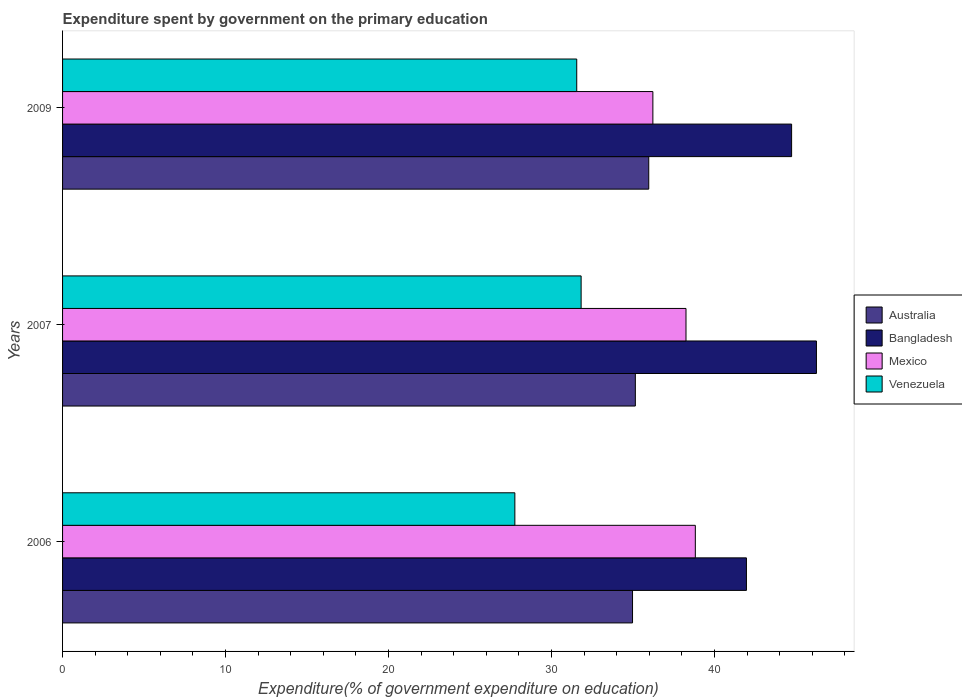How many different coloured bars are there?
Provide a succinct answer. 4. How many groups of bars are there?
Ensure brevity in your answer.  3. Are the number of bars per tick equal to the number of legend labels?
Give a very brief answer. Yes. How many bars are there on the 1st tick from the bottom?
Your answer should be very brief. 4. What is the expenditure spent by government on the primary education in Mexico in 2009?
Offer a very short reply. 36.22. Across all years, what is the maximum expenditure spent by government on the primary education in Mexico?
Your answer should be very brief. 38.82. Across all years, what is the minimum expenditure spent by government on the primary education in Venezuela?
Your answer should be very brief. 27.75. In which year was the expenditure spent by government on the primary education in Australia minimum?
Ensure brevity in your answer.  2006. What is the total expenditure spent by government on the primary education in Mexico in the graph?
Your answer should be compact. 113.29. What is the difference between the expenditure spent by government on the primary education in Australia in 2007 and that in 2009?
Give a very brief answer. -0.82. What is the difference between the expenditure spent by government on the primary education in Australia in 2006 and the expenditure spent by government on the primary education in Bangladesh in 2009?
Your response must be concise. -9.76. What is the average expenditure spent by government on the primary education in Mexico per year?
Provide a succinct answer. 37.76. In the year 2007, what is the difference between the expenditure spent by government on the primary education in Bangladesh and expenditure spent by government on the primary education in Mexico?
Your response must be concise. 8. In how many years, is the expenditure spent by government on the primary education in Australia greater than 46 %?
Your answer should be compact. 0. What is the ratio of the expenditure spent by government on the primary education in Australia in 2006 to that in 2007?
Keep it short and to the point. 1. Is the difference between the expenditure spent by government on the primary education in Bangladesh in 2006 and 2007 greater than the difference between the expenditure spent by government on the primary education in Mexico in 2006 and 2007?
Offer a very short reply. No. What is the difference between the highest and the second highest expenditure spent by government on the primary education in Mexico?
Make the answer very short. 0.57. What is the difference between the highest and the lowest expenditure spent by government on the primary education in Australia?
Make the answer very short. 1. In how many years, is the expenditure spent by government on the primary education in Bangladesh greater than the average expenditure spent by government on the primary education in Bangladesh taken over all years?
Your answer should be very brief. 2. Is the sum of the expenditure spent by government on the primary education in Australia in 2006 and 2007 greater than the maximum expenditure spent by government on the primary education in Venezuela across all years?
Your answer should be compact. Yes. What does the 2nd bar from the top in 2007 represents?
Offer a terse response. Mexico. How many bars are there?
Offer a very short reply. 12. What is the difference between two consecutive major ticks on the X-axis?
Your response must be concise. 10. Are the values on the major ticks of X-axis written in scientific E-notation?
Make the answer very short. No. Where does the legend appear in the graph?
Ensure brevity in your answer.  Center right. How many legend labels are there?
Your response must be concise. 4. What is the title of the graph?
Your answer should be very brief. Expenditure spent by government on the primary education. What is the label or title of the X-axis?
Provide a short and direct response. Expenditure(% of government expenditure on education). What is the label or title of the Y-axis?
Ensure brevity in your answer.  Years. What is the Expenditure(% of government expenditure on education) of Australia in 2006?
Ensure brevity in your answer.  34.97. What is the Expenditure(% of government expenditure on education) in Bangladesh in 2006?
Offer a terse response. 41.96. What is the Expenditure(% of government expenditure on education) of Mexico in 2006?
Provide a succinct answer. 38.82. What is the Expenditure(% of government expenditure on education) of Venezuela in 2006?
Give a very brief answer. 27.75. What is the Expenditure(% of government expenditure on education) of Australia in 2007?
Keep it short and to the point. 35.14. What is the Expenditure(% of government expenditure on education) of Bangladesh in 2007?
Your answer should be very brief. 46.25. What is the Expenditure(% of government expenditure on education) of Mexico in 2007?
Keep it short and to the point. 38.25. What is the Expenditure(% of government expenditure on education) in Venezuela in 2007?
Keep it short and to the point. 31.81. What is the Expenditure(% of government expenditure on education) in Australia in 2009?
Your response must be concise. 35.96. What is the Expenditure(% of government expenditure on education) of Bangladesh in 2009?
Provide a succinct answer. 44.73. What is the Expenditure(% of government expenditure on education) in Mexico in 2009?
Your answer should be very brief. 36.22. What is the Expenditure(% of government expenditure on education) in Venezuela in 2009?
Offer a very short reply. 31.55. Across all years, what is the maximum Expenditure(% of government expenditure on education) in Australia?
Make the answer very short. 35.96. Across all years, what is the maximum Expenditure(% of government expenditure on education) of Bangladesh?
Provide a succinct answer. 46.25. Across all years, what is the maximum Expenditure(% of government expenditure on education) in Mexico?
Keep it short and to the point. 38.82. Across all years, what is the maximum Expenditure(% of government expenditure on education) in Venezuela?
Make the answer very short. 31.81. Across all years, what is the minimum Expenditure(% of government expenditure on education) in Australia?
Your answer should be very brief. 34.97. Across all years, what is the minimum Expenditure(% of government expenditure on education) in Bangladesh?
Offer a very short reply. 41.96. Across all years, what is the minimum Expenditure(% of government expenditure on education) of Mexico?
Your response must be concise. 36.22. Across all years, what is the minimum Expenditure(% of government expenditure on education) in Venezuela?
Your answer should be compact. 27.75. What is the total Expenditure(% of government expenditure on education) in Australia in the graph?
Your answer should be compact. 106.07. What is the total Expenditure(% of government expenditure on education) of Bangladesh in the graph?
Offer a terse response. 132.94. What is the total Expenditure(% of government expenditure on education) in Mexico in the graph?
Offer a very short reply. 113.29. What is the total Expenditure(% of government expenditure on education) in Venezuela in the graph?
Offer a very short reply. 91.11. What is the difference between the Expenditure(% of government expenditure on education) of Australia in 2006 and that in 2007?
Ensure brevity in your answer.  -0.17. What is the difference between the Expenditure(% of government expenditure on education) of Bangladesh in 2006 and that in 2007?
Offer a very short reply. -4.29. What is the difference between the Expenditure(% of government expenditure on education) of Mexico in 2006 and that in 2007?
Provide a short and direct response. 0.57. What is the difference between the Expenditure(% of government expenditure on education) in Venezuela in 2006 and that in 2007?
Provide a succinct answer. -4.07. What is the difference between the Expenditure(% of government expenditure on education) of Australia in 2006 and that in 2009?
Your response must be concise. -1. What is the difference between the Expenditure(% of government expenditure on education) in Bangladesh in 2006 and that in 2009?
Ensure brevity in your answer.  -2.77. What is the difference between the Expenditure(% of government expenditure on education) of Mexico in 2006 and that in 2009?
Your answer should be compact. 2.6. What is the difference between the Expenditure(% of government expenditure on education) in Venezuela in 2006 and that in 2009?
Ensure brevity in your answer.  -3.8. What is the difference between the Expenditure(% of government expenditure on education) of Australia in 2007 and that in 2009?
Offer a very short reply. -0.82. What is the difference between the Expenditure(% of government expenditure on education) of Bangladesh in 2007 and that in 2009?
Give a very brief answer. 1.52. What is the difference between the Expenditure(% of government expenditure on education) of Mexico in 2007 and that in 2009?
Provide a short and direct response. 2.03. What is the difference between the Expenditure(% of government expenditure on education) of Venezuela in 2007 and that in 2009?
Give a very brief answer. 0.27. What is the difference between the Expenditure(% of government expenditure on education) in Australia in 2006 and the Expenditure(% of government expenditure on education) in Bangladesh in 2007?
Your answer should be compact. -11.28. What is the difference between the Expenditure(% of government expenditure on education) of Australia in 2006 and the Expenditure(% of government expenditure on education) of Mexico in 2007?
Your answer should be compact. -3.28. What is the difference between the Expenditure(% of government expenditure on education) in Australia in 2006 and the Expenditure(% of government expenditure on education) in Venezuela in 2007?
Your answer should be very brief. 3.15. What is the difference between the Expenditure(% of government expenditure on education) in Bangladesh in 2006 and the Expenditure(% of government expenditure on education) in Mexico in 2007?
Your answer should be compact. 3.71. What is the difference between the Expenditure(% of government expenditure on education) in Bangladesh in 2006 and the Expenditure(% of government expenditure on education) in Venezuela in 2007?
Keep it short and to the point. 10.14. What is the difference between the Expenditure(% of government expenditure on education) of Mexico in 2006 and the Expenditure(% of government expenditure on education) of Venezuela in 2007?
Provide a succinct answer. 7.01. What is the difference between the Expenditure(% of government expenditure on education) in Australia in 2006 and the Expenditure(% of government expenditure on education) in Bangladesh in 2009?
Your answer should be compact. -9.76. What is the difference between the Expenditure(% of government expenditure on education) of Australia in 2006 and the Expenditure(% of government expenditure on education) of Mexico in 2009?
Offer a terse response. -1.25. What is the difference between the Expenditure(% of government expenditure on education) in Australia in 2006 and the Expenditure(% of government expenditure on education) in Venezuela in 2009?
Ensure brevity in your answer.  3.42. What is the difference between the Expenditure(% of government expenditure on education) in Bangladesh in 2006 and the Expenditure(% of government expenditure on education) in Mexico in 2009?
Keep it short and to the point. 5.74. What is the difference between the Expenditure(% of government expenditure on education) in Bangladesh in 2006 and the Expenditure(% of government expenditure on education) in Venezuela in 2009?
Offer a terse response. 10.41. What is the difference between the Expenditure(% of government expenditure on education) in Mexico in 2006 and the Expenditure(% of government expenditure on education) in Venezuela in 2009?
Your response must be concise. 7.28. What is the difference between the Expenditure(% of government expenditure on education) in Australia in 2007 and the Expenditure(% of government expenditure on education) in Bangladesh in 2009?
Offer a very short reply. -9.59. What is the difference between the Expenditure(% of government expenditure on education) in Australia in 2007 and the Expenditure(% of government expenditure on education) in Mexico in 2009?
Provide a short and direct response. -1.08. What is the difference between the Expenditure(% of government expenditure on education) in Australia in 2007 and the Expenditure(% of government expenditure on education) in Venezuela in 2009?
Your response must be concise. 3.6. What is the difference between the Expenditure(% of government expenditure on education) of Bangladesh in 2007 and the Expenditure(% of government expenditure on education) of Mexico in 2009?
Ensure brevity in your answer.  10.04. What is the difference between the Expenditure(% of government expenditure on education) in Bangladesh in 2007 and the Expenditure(% of government expenditure on education) in Venezuela in 2009?
Your answer should be very brief. 14.71. What is the difference between the Expenditure(% of government expenditure on education) in Mexico in 2007 and the Expenditure(% of government expenditure on education) in Venezuela in 2009?
Offer a terse response. 6.7. What is the average Expenditure(% of government expenditure on education) in Australia per year?
Give a very brief answer. 35.36. What is the average Expenditure(% of government expenditure on education) of Bangladesh per year?
Make the answer very short. 44.31. What is the average Expenditure(% of government expenditure on education) in Mexico per year?
Offer a terse response. 37.76. What is the average Expenditure(% of government expenditure on education) in Venezuela per year?
Provide a succinct answer. 30.37. In the year 2006, what is the difference between the Expenditure(% of government expenditure on education) of Australia and Expenditure(% of government expenditure on education) of Bangladesh?
Keep it short and to the point. -6.99. In the year 2006, what is the difference between the Expenditure(% of government expenditure on education) of Australia and Expenditure(% of government expenditure on education) of Mexico?
Provide a succinct answer. -3.85. In the year 2006, what is the difference between the Expenditure(% of government expenditure on education) in Australia and Expenditure(% of government expenditure on education) in Venezuela?
Ensure brevity in your answer.  7.22. In the year 2006, what is the difference between the Expenditure(% of government expenditure on education) in Bangladesh and Expenditure(% of government expenditure on education) in Mexico?
Your response must be concise. 3.14. In the year 2006, what is the difference between the Expenditure(% of government expenditure on education) in Bangladesh and Expenditure(% of government expenditure on education) in Venezuela?
Keep it short and to the point. 14.21. In the year 2006, what is the difference between the Expenditure(% of government expenditure on education) of Mexico and Expenditure(% of government expenditure on education) of Venezuela?
Keep it short and to the point. 11.07. In the year 2007, what is the difference between the Expenditure(% of government expenditure on education) of Australia and Expenditure(% of government expenditure on education) of Bangladesh?
Your response must be concise. -11.11. In the year 2007, what is the difference between the Expenditure(% of government expenditure on education) in Australia and Expenditure(% of government expenditure on education) in Mexico?
Keep it short and to the point. -3.11. In the year 2007, what is the difference between the Expenditure(% of government expenditure on education) in Australia and Expenditure(% of government expenditure on education) in Venezuela?
Your answer should be very brief. 3.33. In the year 2007, what is the difference between the Expenditure(% of government expenditure on education) of Bangladesh and Expenditure(% of government expenditure on education) of Mexico?
Your response must be concise. 8. In the year 2007, what is the difference between the Expenditure(% of government expenditure on education) in Bangladesh and Expenditure(% of government expenditure on education) in Venezuela?
Offer a very short reply. 14.44. In the year 2007, what is the difference between the Expenditure(% of government expenditure on education) of Mexico and Expenditure(% of government expenditure on education) of Venezuela?
Ensure brevity in your answer.  6.43. In the year 2009, what is the difference between the Expenditure(% of government expenditure on education) of Australia and Expenditure(% of government expenditure on education) of Bangladesh?
Give a very brief answer. -8.76. In the year 2009, what is the difference between the Expenditure(% of government expenditure on education) in Australia and Expenditure(% of government expenditure on education) in Mexico?
Your response must be concise. -0.25. In the year 2009, what is the difference between the Expenditure(% of government expenditure on education) in Australia and Expenditure(% of government expenditure on education) in Venezuela?
Offer a terse response. 4.42. In the year 2009, what is the difference between the Expenditure(% of government expenditure on education) of Bangladesh and Expenditure(% of government expenditure on education) of Mexico?
Give a very brief answer. 8.51. In the year 2009, what is the difference between the Expenditure(% of government expenditure on education) of Bangladesh and Expenditure(% of government expenditure on education) of Venezuela?
Your answer should be compact. 13.18. In the year 2009, what is the difference between the Expenditure(% of government expenditure on education) in Mexico and Expenditure(% of government expenditure on education) in Venezuela?
Make the answer very short. 4.67. What is the ratio of the Expenditure(% of government expenditure on education) in Bangladesh in 2006 to that in 2007?
Your response must be concise. 0.91. What is the ratio of the Expenditure(% of government expenditure on education) of Mexico in 2006 to that in 2007?
Make the answer very short. 1.01. What is the ratio of the Expenditure(% of government expenditure on education) of Venezuela in 2006 to that in 2007?
Keep it short and to the point. 0.87. What is the ratio of the Expenditure(% of government expenditure on education) in Australia in 2006 to that in 2009?
Offer a very short reply. 0.97. What is the ratio of the Expenditure(% of government expenditure on education) of Bangladesh in 2006 to that in 2009?
Provide a short and direct response. 0.94. What is the ratio of the Expenditure(% of government expenditure on education) in Mexico in 2006 to that in 2009?
Provide a succinct answer. 1.07. What is the ratio of the Expenditure(% of government expenditure on education) of Venezuela in 2006 to that in 2009?
Your answer should be compact. 0.88. What is the ratio of the Expenditure(% of government expenditure on education) in Australia in 2007 to that in 2009?
Your answer should be compact. 0.98. What is the ratio of the Expenditure(% of government expenditure on education) of Bangladesh in 2007 to that in 2009?
Provide a short and direct response. 1.03. What is the ratio of the Expenditure(% of government expenditure on education) of Mexico in 2007 to that in 2009?
Provide a short and direct response. 1.06. What is the ratio of the Expenditure(% of government expenditure on education) of Venezuela in 2007 to that in 2009?
Provide a succinct answer. 1.01. What is the difference between the highest and the second highest Expenditure(% of government expenditure on education) of Australia?
Provide a succinct answer. 0.82. What is the difference between the highest and the second highest Expenditure(% of government expenditure on education) in Bangladesh?
Offer a very short reply. 1.52. What is the difference between the highest and the second highest Expenditure(% of government expenditure on education) in Mexico?
Ensure brevity in your answer.  0.57. What is the difference between the highest and the second highest Expenditure(% of government expenditure on education) of Venezuela?
Your response must be concise. 0.27. What is the difference between the highest and the lowest Expenditure(% of government expenditure on education) in Bangladesh?
Give a very brief answer. 4.29. What is the difference between the highest and the lowest Expenditure(% of government expenditure on education) of Mexico?
Offer a terse response. 2.6. What is the difference between the highest and the lowest Expenditure(% of government expenditure on education) in Venezuela?
Ensure brevity in your answer.  4.07. 